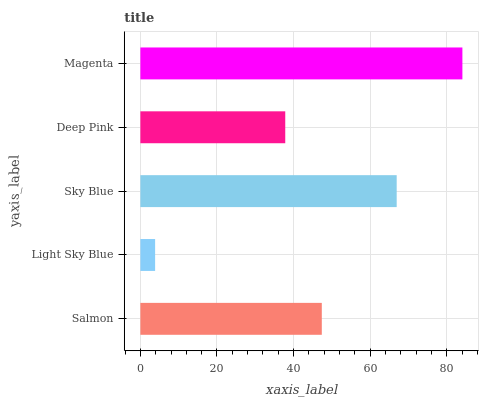Is Light Sky Blue the minimum?
Answer yes or no. Yes. Is Magenta the maximum?
Answer yes or no. Yes. Is Sky Blue the minimum?
Answer yes or no. No. Is Sky Blue the maximum?
Answer yes or no. No. Is Sky Blue greater than Light Sky Blue?
Answer yes or no. Yes. Is Light Sky Blue less than Sky Blue?
Answer yes or no. Yes. Is Light Sky Blue greater than Sky Blue?
Answer yes or no. No. Is Sky Blue less than Light Sky Blue?
Answer yes or no. No. Is Salmon the high median?
Answer yes or no. Yes. Is Salmon the low median?
Answer yes or no. Yes. Is Light Sky Blue the high median?
Answer yes or no. No. Is Magenta the low median?
Answer yes or no. No. 